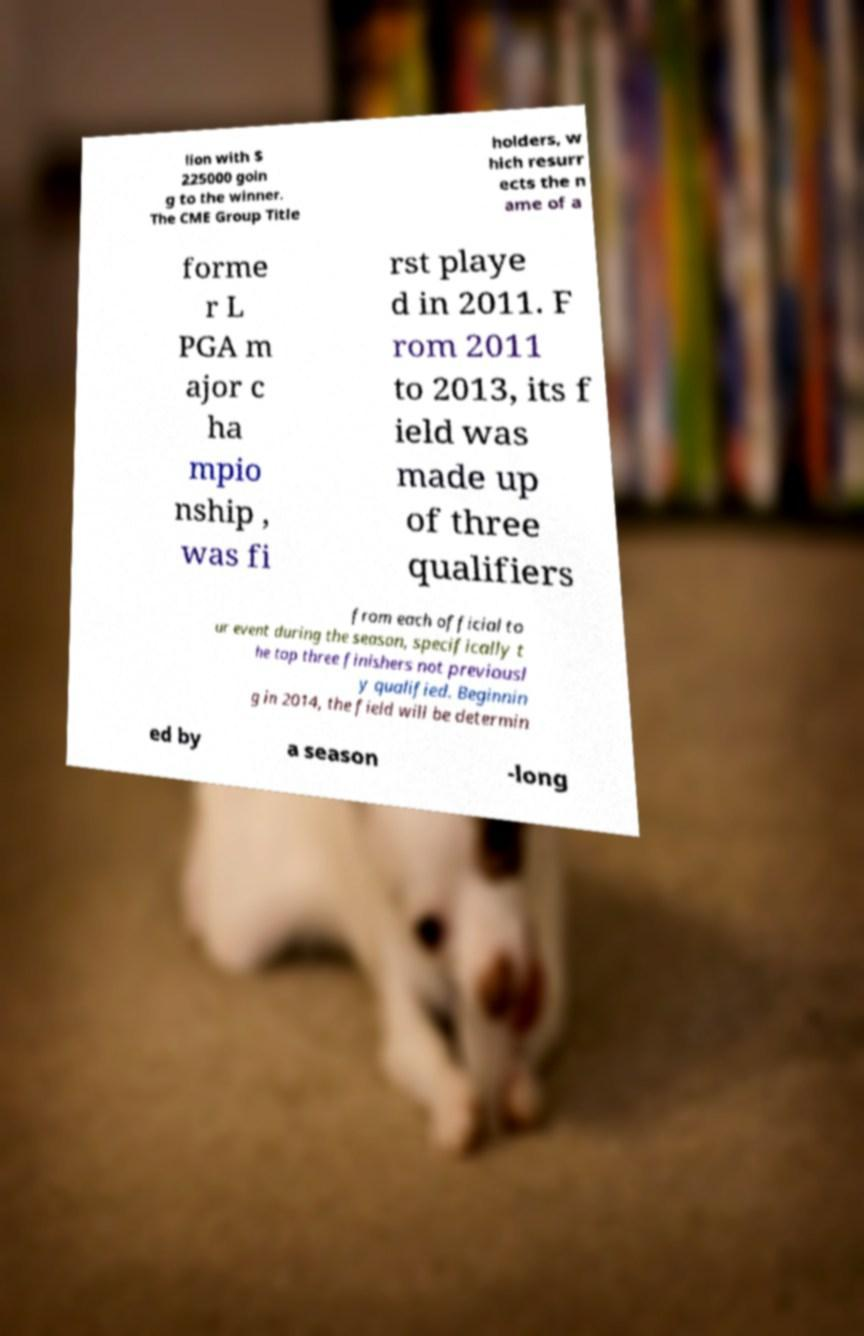Please identify and transcribe the text found in this image. lion with $ 225000 goin g to the winner. The CME Group Title holders, w hich resurr ects the n ame of a forme r L PGA m ajor c ha mpio nship , was fi rst playe d in 2011. F rom 2011 to 2013, its f ield was made up of three qualifiers from each official to ur event during the season, specifically t he top three finishers not previousl y qualified. Beginnin g in 2014, the field will be determin ed by a season -long 